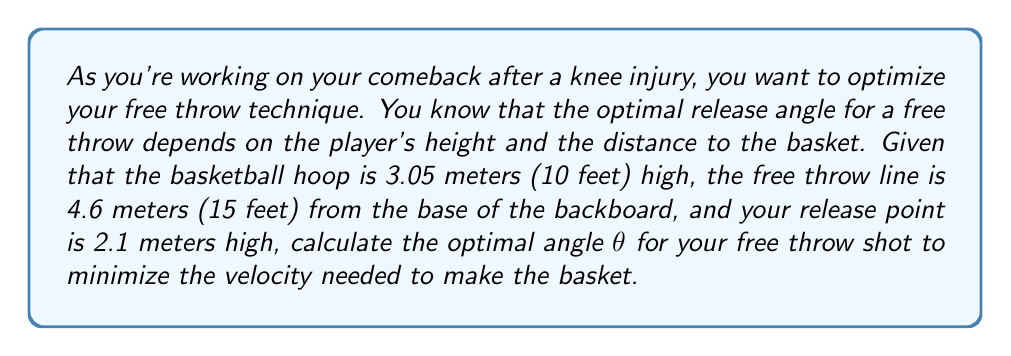Solve this math problem. To solve this problem, we'll use principles of projectile motion and trigonometry. Let's break it down step-by-step:

1) First, let's define our variables:
   $h$ = height of the hoop = 3.05 m
   $d$ = horizontal distance to the hoop = 4.6 m
   $y_0$ = initial height of the ball (your release point) = 2.1 m
   $θ$ = release angle (what we're solving for)

2) The vertical distance the ball needs to travel is:
   $Δy = h - y_0 = 3.05 - 2.1 = 0.95$ m

3) In projectile motion, the optimal angle to reach a target with minimum velocity occurs when the vertical component of the velocity at the target is zero. This happens when the ball reaches its maximum height at the hoop.

4) Using this principle, we can set up the equation:
   $\tan θ = \frac{2Δy}{d}$

5) Substituting our values:
   $\tan θ = \frac{2(0.95)}{4.6} = \frac{1.9}{4.6}$

6) To solve for θ, we take the inverse tangent (arctan) of both sides:
   $θ = \arctan(\frac{1.9}{4.6})$

7) Using a calculator or computer:
   $θ ≈ 22.4°$

This angle will minimize the velocity needed for the shot, which is crucial for maintaining accuracy while you're still recovering from your knee injury.

[asy]
import geometry;

size(200);

real d = 4.6;
real h = 3.05;
real y0 = 2.1;
real theta = 22.4 * pi / 180;

pair O = (0,0);
pair A = (0,y0);
pair B = (d,h);

draw(O--A--B--O);
draw(A--(d,y0), dashed);
draw(Arc(A,0.5,0,theta), Arrow);

label("θ", (0.3,y0+0.3));
label("4.6 m", (d/2,0), S);
label("3.05 m", (d,h/2), E);
label("2.1 m", (0,y0/2), W);

dot("Release point", A, NW);
dot("Hoop", B, NE);
[/asy]
Answer: The optimal angle for the free throw shot is approximately $22.4°$. 